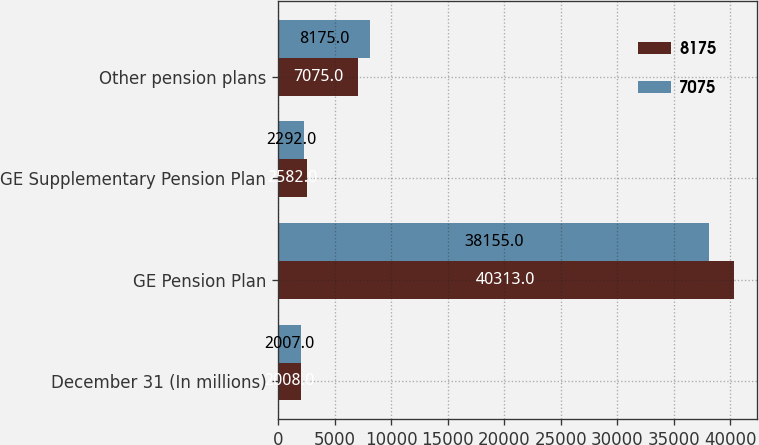<chart> <loc_0><loc_0><loc_500><loc_500><stacked_bar_chart><ecel><fcel>December 31 (In millions)<fcel>GE Pension Plan<fcel>GE Supplementary Pension Plan<fcel>Other pension plans<nl><fcel>8175<fcel>2008<fcel>40313<fcel>2582<fcel>7075<nl><fcel>7075<fcel>2007<fcel>38155<fcel>2292<fcel>8175<nl></chart> 